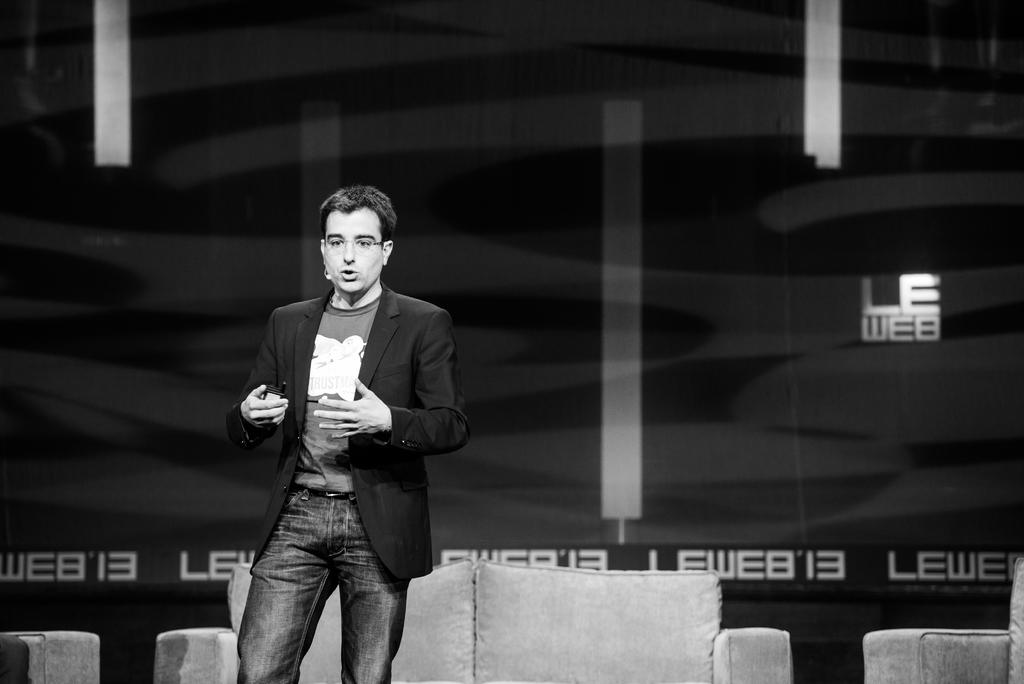What type of furniture is located on the left side of the image? There is a sofa on the left side of the image. What type of furniture is located on the right side of the image? There is a sofa on the right side of the image. What is the position of the person in the image? There is a person standing in the foreground of the image. What can be seen in the background of the image? There appears to be a banner in the background of the image. What type of ant is crawling on the person's skirt in the image? There is no ant or skirt present in the image; the person is standing and there is no mention of any clothing. 